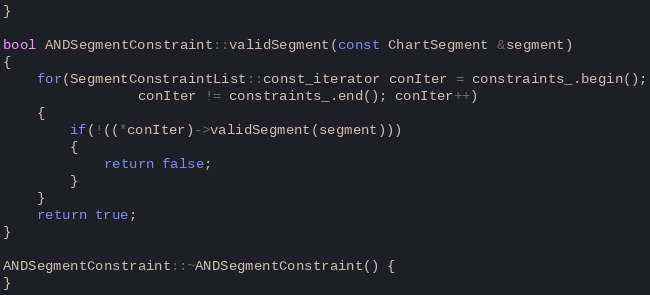Convert code to text. <code><loc_0><loc_0><loc_500><loc_500><_C++_>}

bool ANDSegmentConstraint::validSegment(const ChartSegment &segment)
{
	for(SegmentConstraintList::const_iterator conIter = constraints_.begin();
				conIter != constraints_.end(); conIter++)
	{
		if(!((*conIter)->validSegment(segment)))
		{
			return false;
		}
	}
	return true;
}

ANDSegmentConstraint::~ANDSegmentConstraint() {
}

</code> 